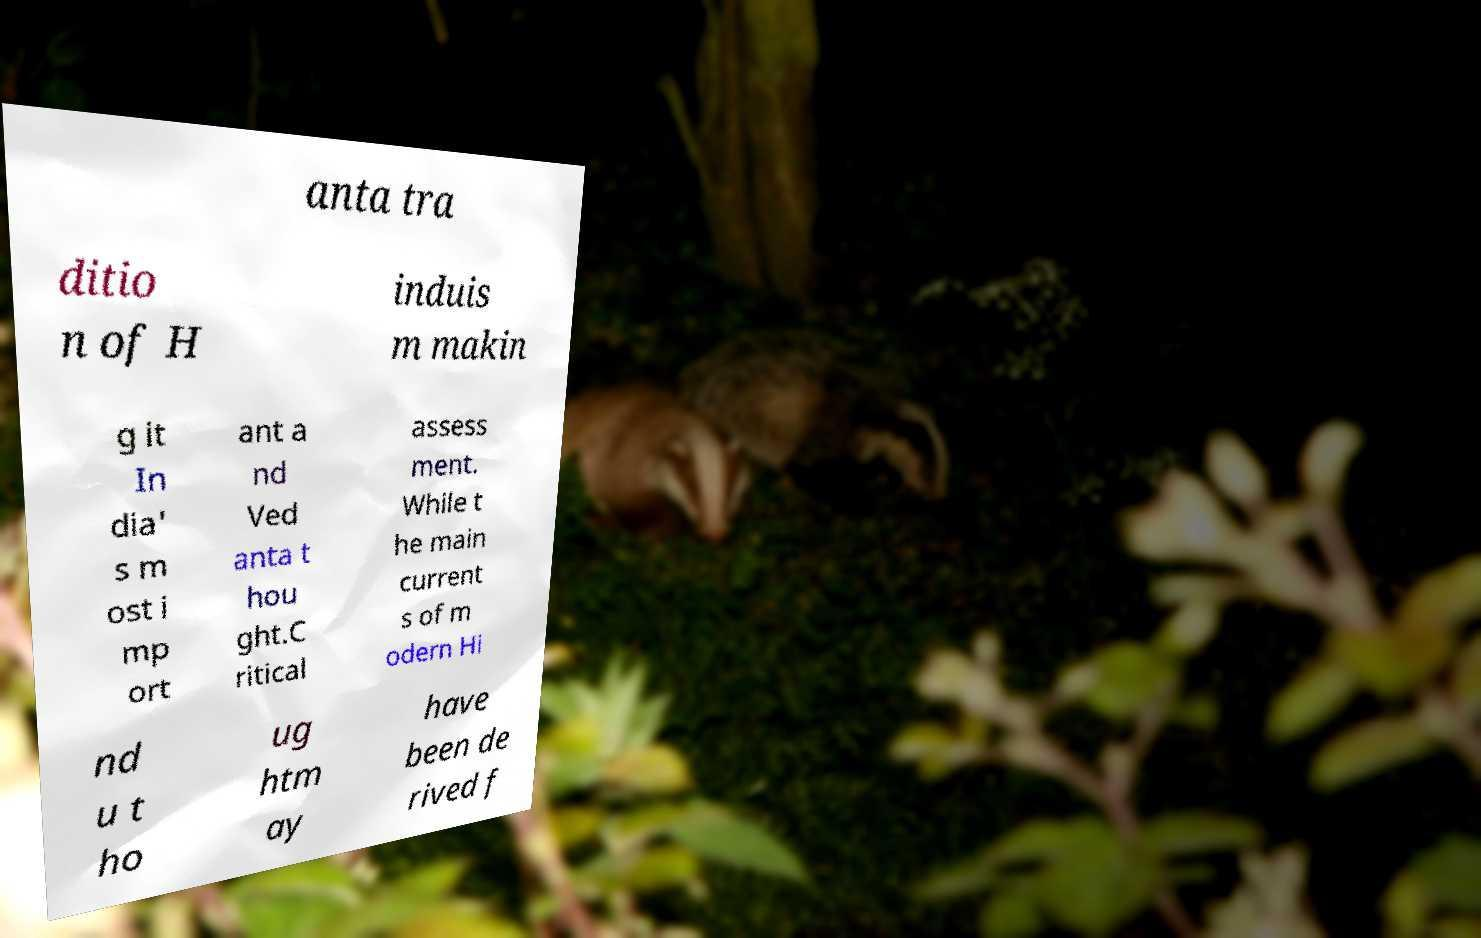Could you assist in decoding the text presented in this image and type it out clearly? anta tra ditio n of H induis m makin g it In dia' s m ost i mp ort ant a nd Ved anta t hou ght.C ritical assess ment. While t he main current s of m odern Hi nd u t ho ug htm ay have been de rived f 